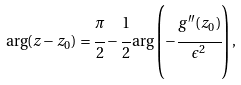Convert formula to latex. <formula><loc_0><loc_0><loc_500><loc_500>\arg ( z - z _ { 0 } ) = \cfrac { \pi } { 2 } - \cfrac { 1 } { 2 } \arg \left ( - \cfrac { g ^ { \prime \prime } ( z _ { 0 } ) } { \epsilon ^ { 2 } } \right ) ,</formula> 